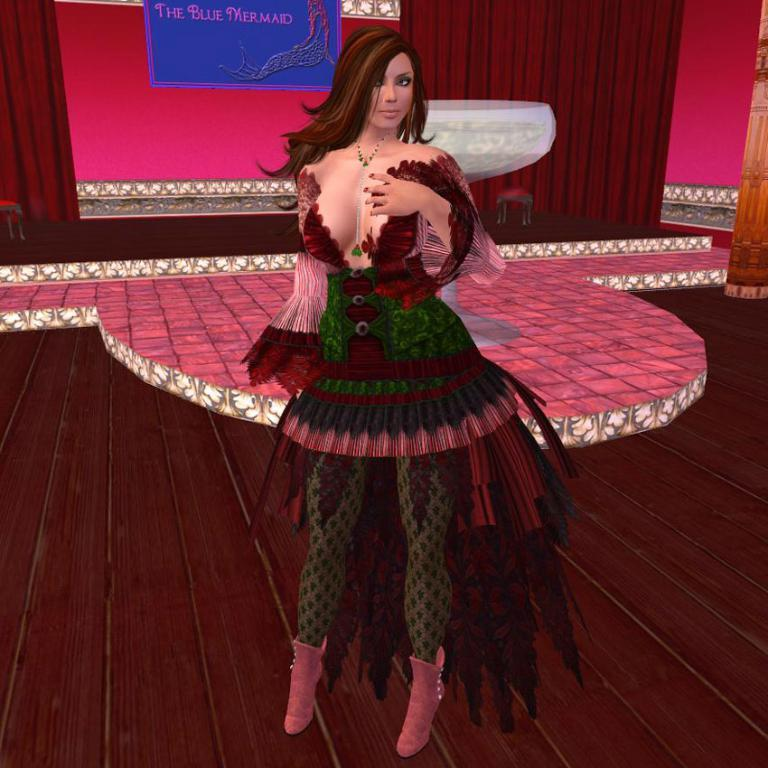What is the main subject of the image? There is a statue of a woman in the image. How is the statue positioned in the image? The statue is standing on the floor. What can be seen in the background of the image? There are curtains in the background of the image. What type of quill is the statue holding in the image? There is no quill present in the image; the statue is not holding any object. 